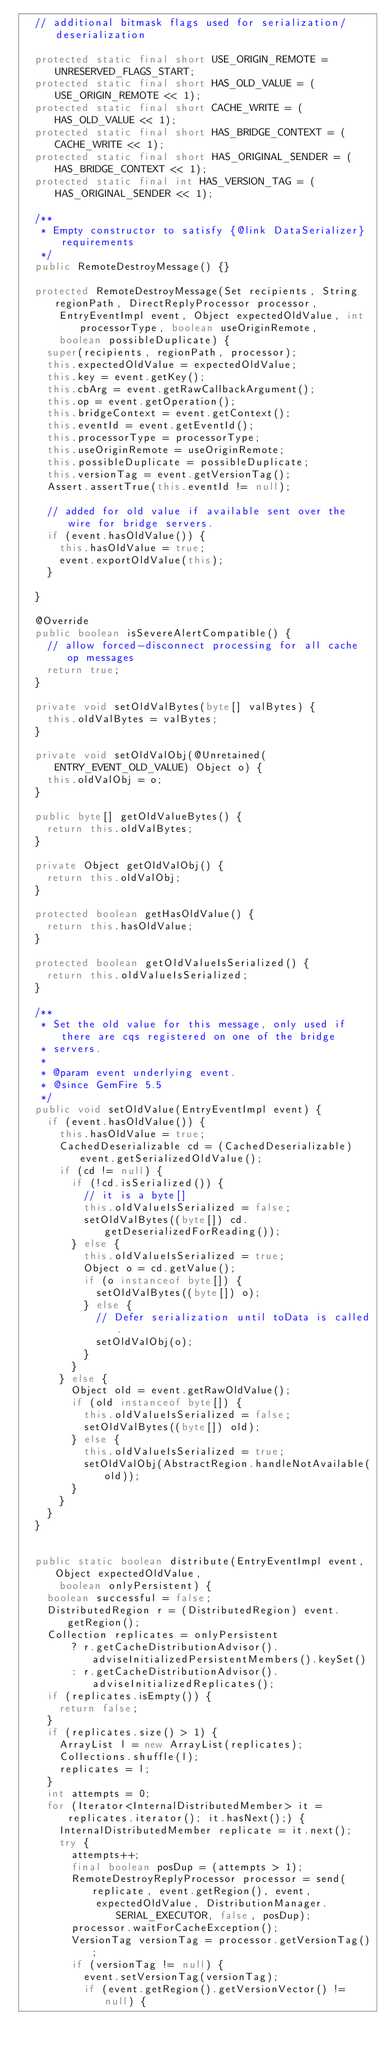<code> <loc_0><loc_0><loc_500><loc_500><_Java_>  // additional bitmask flags used for serialization/deserialization

  protected static final short USE_ORIGIN_REMOTE = UNRESERVED_FLAGS_START;
  protected static final short HAS_OLD_VALUE = (USE_ORIGIN_REMOTE << 1);
  protected static final short CACHE_WRITE = (HAS_OLD_VALUE << 1);
  protected static final short HAS_BRIDGE_CONTEXT = (CACHE_WRITE << 1);
  protected static final short HAS_ORIGINAL_SENDER = (HAS_BRIDGE_CONTEXT << 1);
  protected static final int HAS_VERSION_TAG = (HAS_ORIGINAL_SENDER << 1);

  /**
   * Empty constructor to satisfy {@link DataSerializer} requirements
   */
  public RemoteDestroyMessage() {}

  protected RemoteDestroyMessage(Set recipients, String regionPath, DirectReplyProcessor processor,
      EntryEventImpl event, Object expectedOldValue, int processorType, boolean useOriginRemote,
      boolean possibleDuplicate) {
    super(recipients, regionPath, processor);
    this.expectedOldValue = expectedOldValue;
    this.key = event.getKey();
    this.cbArg = event.getRawCallbackArgument();
    this.op = event.getOperation();
    this.bridgeContext = event.getContext();
    this.eventId = event.getEventId();
    this.processorType = processorType;
    this.useOriginRemote = useOriginRemote;
    this.possibleDuplicate = possibleDuplicate;
    this.versionTag = event.getVersionTag();
    Assert.assertTrue(this.eventId != null);

    // added for old value if available sent over the wire for bridge servers.
    if (event.hasOldValue()) {
      this.hasOldValue = true;
      event.exportOldValue(this);
    }

  }

  @Override
  public boolean isSevereAlertCompatible() {
    // allow forced-disconnect processing for all cache op messages
    return true;
  }

  private void setOldValBytes(byte[] valBytes) {
    this.oldValBytes = valBytes;
  }

  private void setOldValObj(@Unretained(ENTRY_EVENT_OLD_VALUE) Object o) {
    this.oldValObj = o;
  }

  public byte[] getOldValueBytes() {
    return this.oldValBytes;
  }

  private Object getOldValObj() {
    return this.oldValObj;
  }

  protected boolean getHasOldValue() {
    return this.hasOldValue;
  }

  protected boolean getOldValueIsSerialized() {
    return this.oldValueIsSerialized;
  }

  /**
   * Set the old value for this message, only used if there are cqs registered on one of the bridge
   * servers.
   * 
   * @param event underlying event.
   * @since GemFire 5.5
   */
  public void setOldValue(EntryEventImpl event) {
    if (event.hasOldValue()) {
      this.hasOldValue = true;
      CachedDeserializable cd = (CachedDeserializable) event.getSerializedOldValue();
      if (cd != null) {
        if (!cd.isSerialized()) {
          // it is a byte[]
          this.oldValueIsSerialized = false;
          setOldValBytes((byte[]) cd.getDeserializedForReading());
        } else {
          this.oldValueIsSerialized = true;
          Object o = cd.getValue();
          if (o instanceof byte[]) {
            setOldValBytes((byte[]) o);
          } else {
            // Defer serialization until toData is called.
            setOldValObj(o);
          }
        }
      } else {
        Object old = event.getRawOldValue();
        if (old instanceof byte[]) {
          this.oldValueIsSerialized = false;
          setOldValBytes((byte[]) old);
        } else {
          this.oldValueIsSerialized = true;
          setOldValObj(AbstractRegion.handleNotAvailable(old));
        }
      }
    }
  }


  public static boolean distribute(EntryEventImpl event, Object expectedOldValue,
      boolean onlyPersistent) {
    boolean successful = false;
    DistributedRegion r = (DistributedRegion) event.getRegion();
    Collection replicates = onlyPersistent
        ? r.getCacheDistributionAdvisor().adviseInitializedPersistentMembers().keySet()
        : r.getCacheDistributionAdvisor().adviseInitializedReplicates();
    if (replicates.isEmpty()) {
      return false;
    }
    if (replicates.size() > 1) {
      ArrayList l = new ArrayList(replicates);
      Collections.shuffle(l);
      replicates = l;
    }
    int attempts = 0;
    for (Iterator<InternalDistributedMember> it = replicates.iterator(); it.hasNext();) {
      InternalDistributedMember replicate = it.next();
      try {
        attempts++;
        final boolean posDup = (attempts > 1);
        RemoteDestroyReplyProcessor processor = send(replicate, event.getRegion(), event,
            expectedOldValue, DistributionManager.SERIAL_EXECUTOR, false, posDup);
        processor.waitForCacheException();
        VersionTag versionTag = processor.getVersionTag();
        if (versionTag != null) {
          event.setVersionTag(versionTag);
          if (event.getRegion().getVersionVector() != null) {</code> 